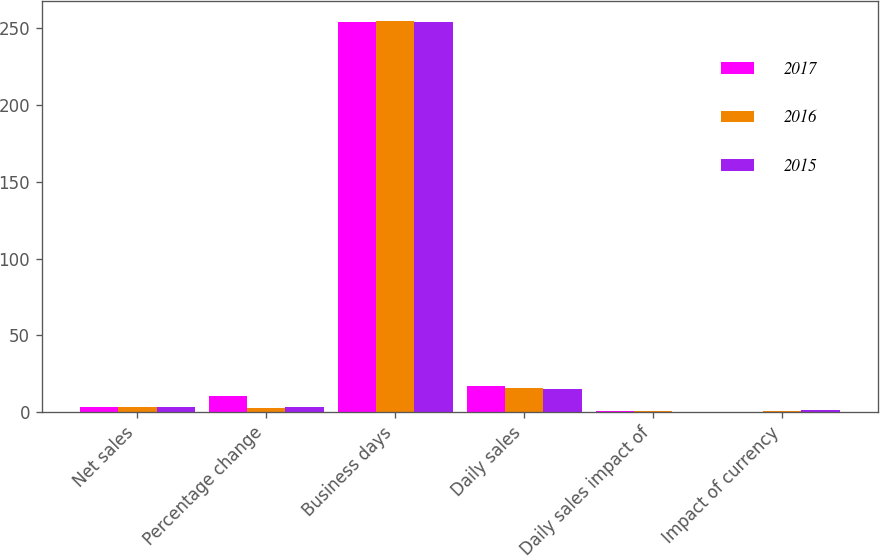Convert chart to OTSL. <chart><loc_0><loc_0><loc_500><loc_500><stacked_bar_chart><ecel><fcel>Net sales<fcel>Percentage change<fcel>Business days<fcel>Daily sales<fcel>Daily sales impact of<fcel>Impact of currency<nl><fcel>2017<fcel>3.6<fcel>10.8<fcel>254<fcel>17.3<fcel>1<fcel>0.1<nl><fcel>2016<fcel>3.6<fcel>2.4<fcel>255<fcel>15.5<fcel>0.6<fcel>0.4<nl><fcel>2015<fcel>3.6<fcel>3.6<fcel>254<fcel>15.2<fcel>0.2<fcel>1.2<nl></chart> 